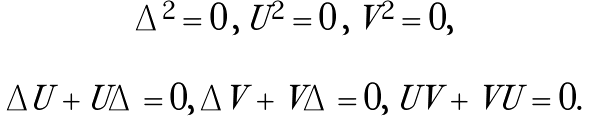<formula> <loc_0><loc_0><loc_500><loc_500>\begin{array} { c c } \Delta ^ { 2 } = 0 \, , \, U ^ { 2 } = 0 \, , \, V ^ { 2 } = 0 , & \\ & \\ \Delta U + U \Delta = 0 , \, \Delta V + V \Delta = 0 , \, U V + V U = 0 . & \end{array}</formula> 